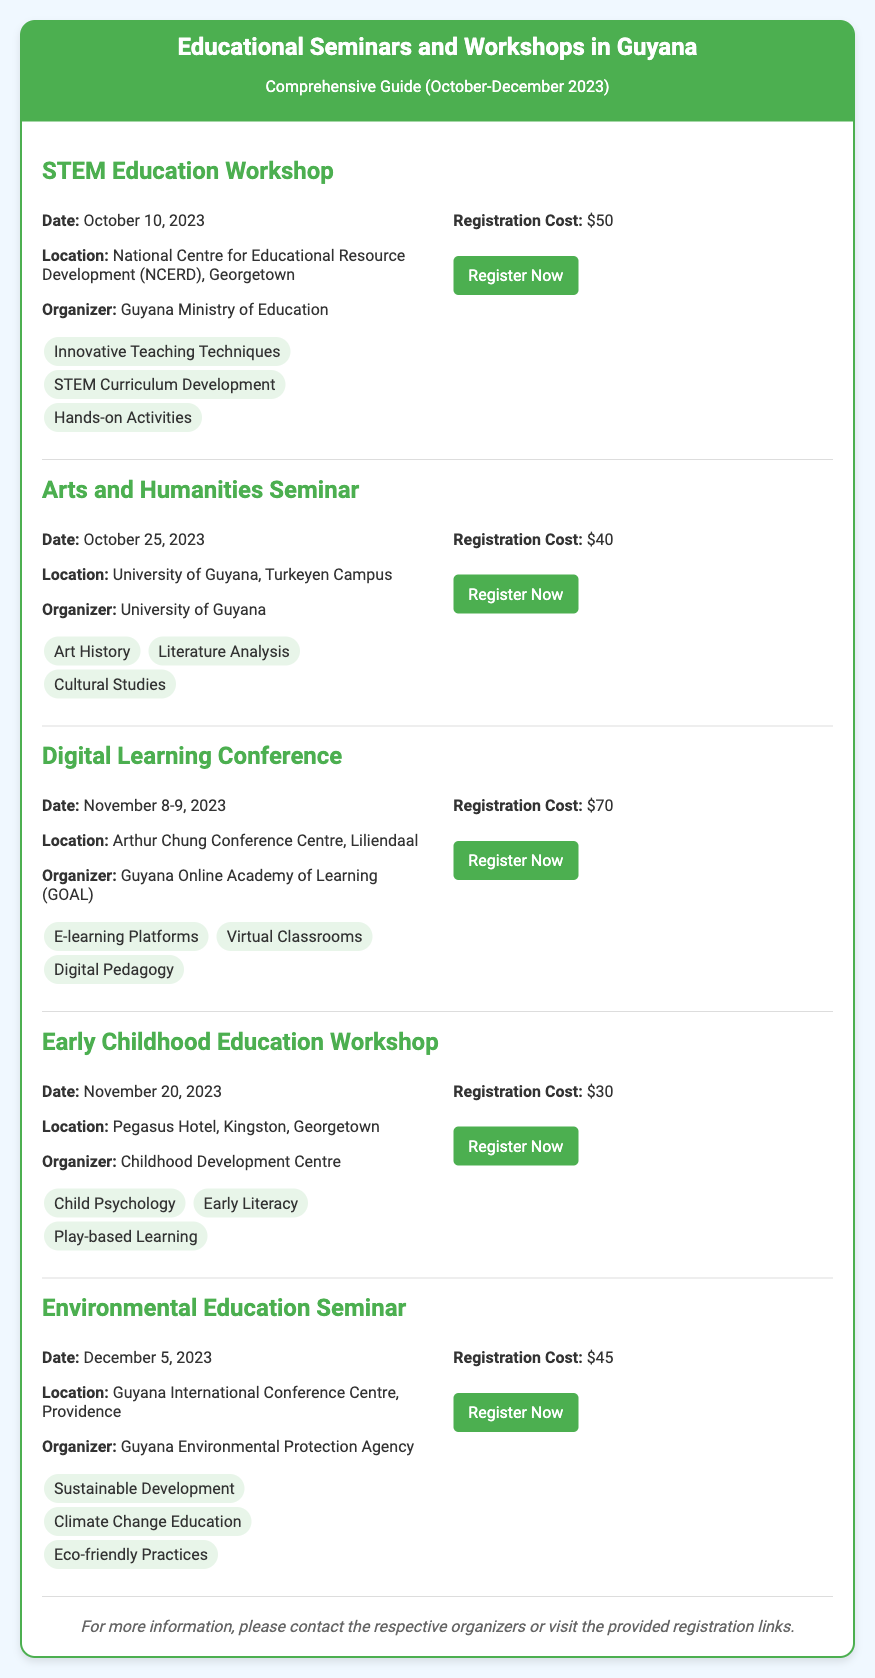What is the date of the STEM Education Workshop? The date is explicitly mentioned in the event details of the STEM Education Workshop section.
Answer: October 10, 2023 Where will the Digital Learning Conference be held? The location for the Digital Learning Conference is specified in the event details as part of the document.
Answer: Arthur Chung Conference Centre, Liliendaal What is the registration cost for the Early Childhood Education Workshop? The registration cost is detailed in the registration information for the Early Childhood Education Workshop.
Answer: $30 Which topic is covered in the Arts and Humanities Seminar? The topics are listed in the event details, and at least one topic must be selected from that section.
Answer: Art History Who is organizing the Environmental Education Seminar? The organizer's information is provided in the event details for the Environmental Education Seminar.
Answer: Guyana Environmental Protection Agency How many days will the Digital Learning Conference last? The duration can be inferred from the dates mentioned for the Digital Learning Conference.
Answer: 2 days What is the main theme of the STEM Education Workshop? The themes are identified by the topics covered in the workshop's event details.
Answer: Innovative Teaching Techniques When is the Arts and Humanities Seminar scheduled? The schedule is provided in the event details section of the seminar.
Answer: October 25, 2023 What type of document is this? The structure and content of the document indicate that it serves a specific purpose related to educational events.
Answer: Ticket 